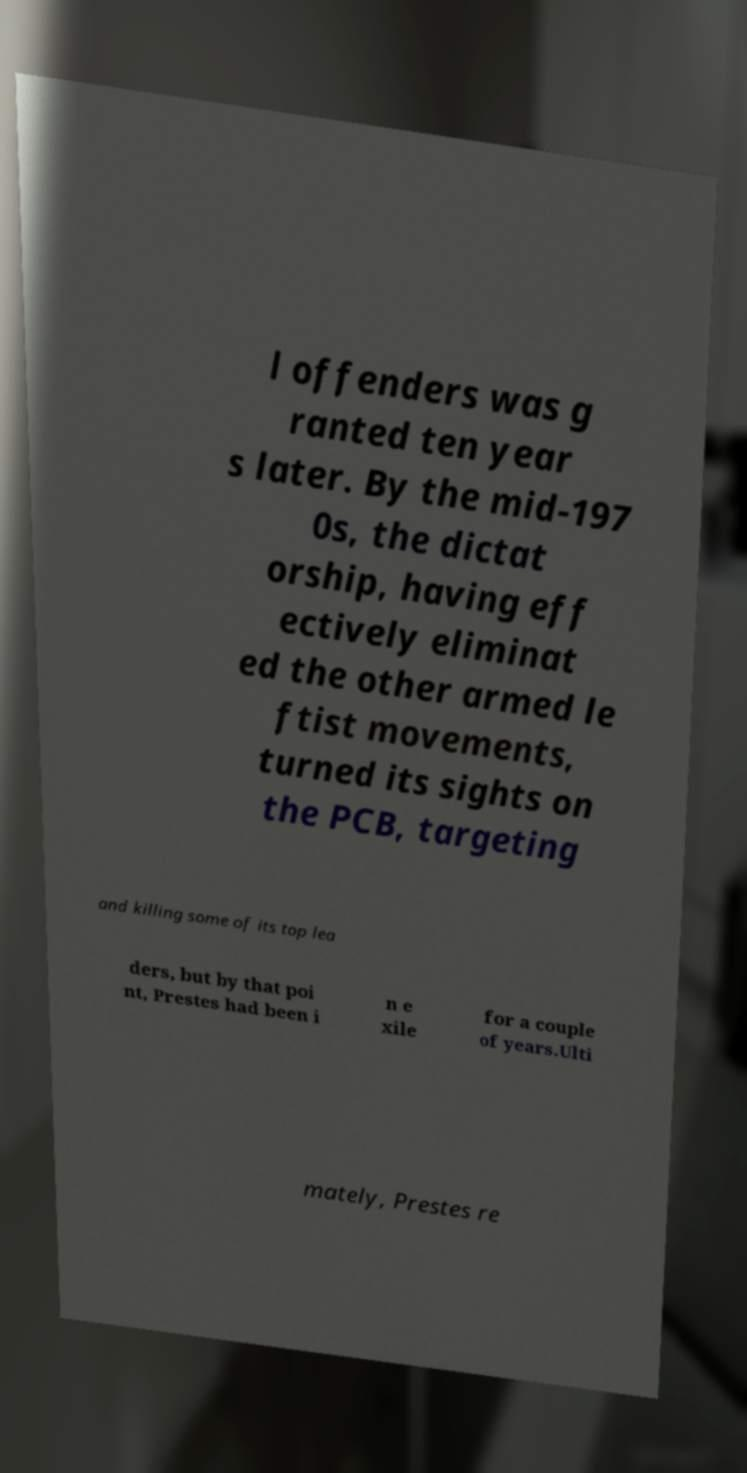Please identify and transcribe the text found in this image. l offenders was g ranted ten year s later. By the mid-197 0s, the dictat orship, having eff ectively eliminat ed the other armed le ftist movements, turned its sights on the PCB, targeting and killing some of its top lea ders, but by that poi nt, Prestes had been i n e xile for a couple of years.Ulti mately, Prestes re 